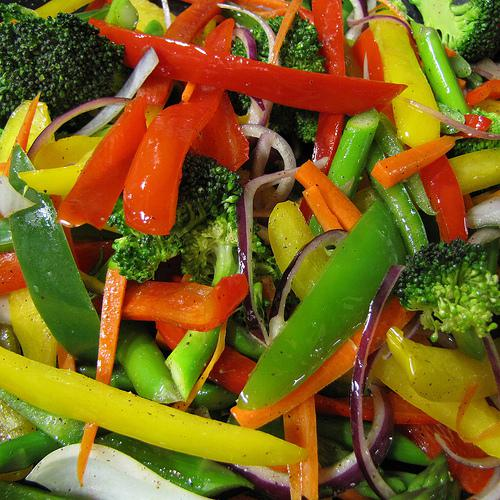Question: what color is the broccoli?
Choices:
A. Brown.
B. Yellow.
C. Black.
D. Green.
Answer with the letter. Answer: D Question: what color are the onions?
Choices:
A. Yellow.
B. Red.
C. Orange.
D. Purple and white.
Answer with the letter. Answer: D Question: where is the broccoli?
Choices:
A. In the bowl.
B. In the pot.
C. In the pasta.
D. In the salad.
Answer with the letter. Answer: D Question: how many vegetables are there?
Choices:
A. 8.
B. 6.
C. 7.
D. 5.
Answer with the letter. Answer: D Question: what color are the peppers?
Choices:
A. Orange.
B. Purple.
C. Red, yellow, and green.
D. Red-orange.
Answer with the letter. Answer: C Question: what color are the green beans?
Choices:
A. Yellow.
B. Brown.
C. Black and green.
D. Green and white.
Answer with the letter. Answer: D Question: what color are the carrots?
Choices:
A. White.
B. Green.
C. Orange.
D. Yellow.
Answer with the letter. Answer: C 